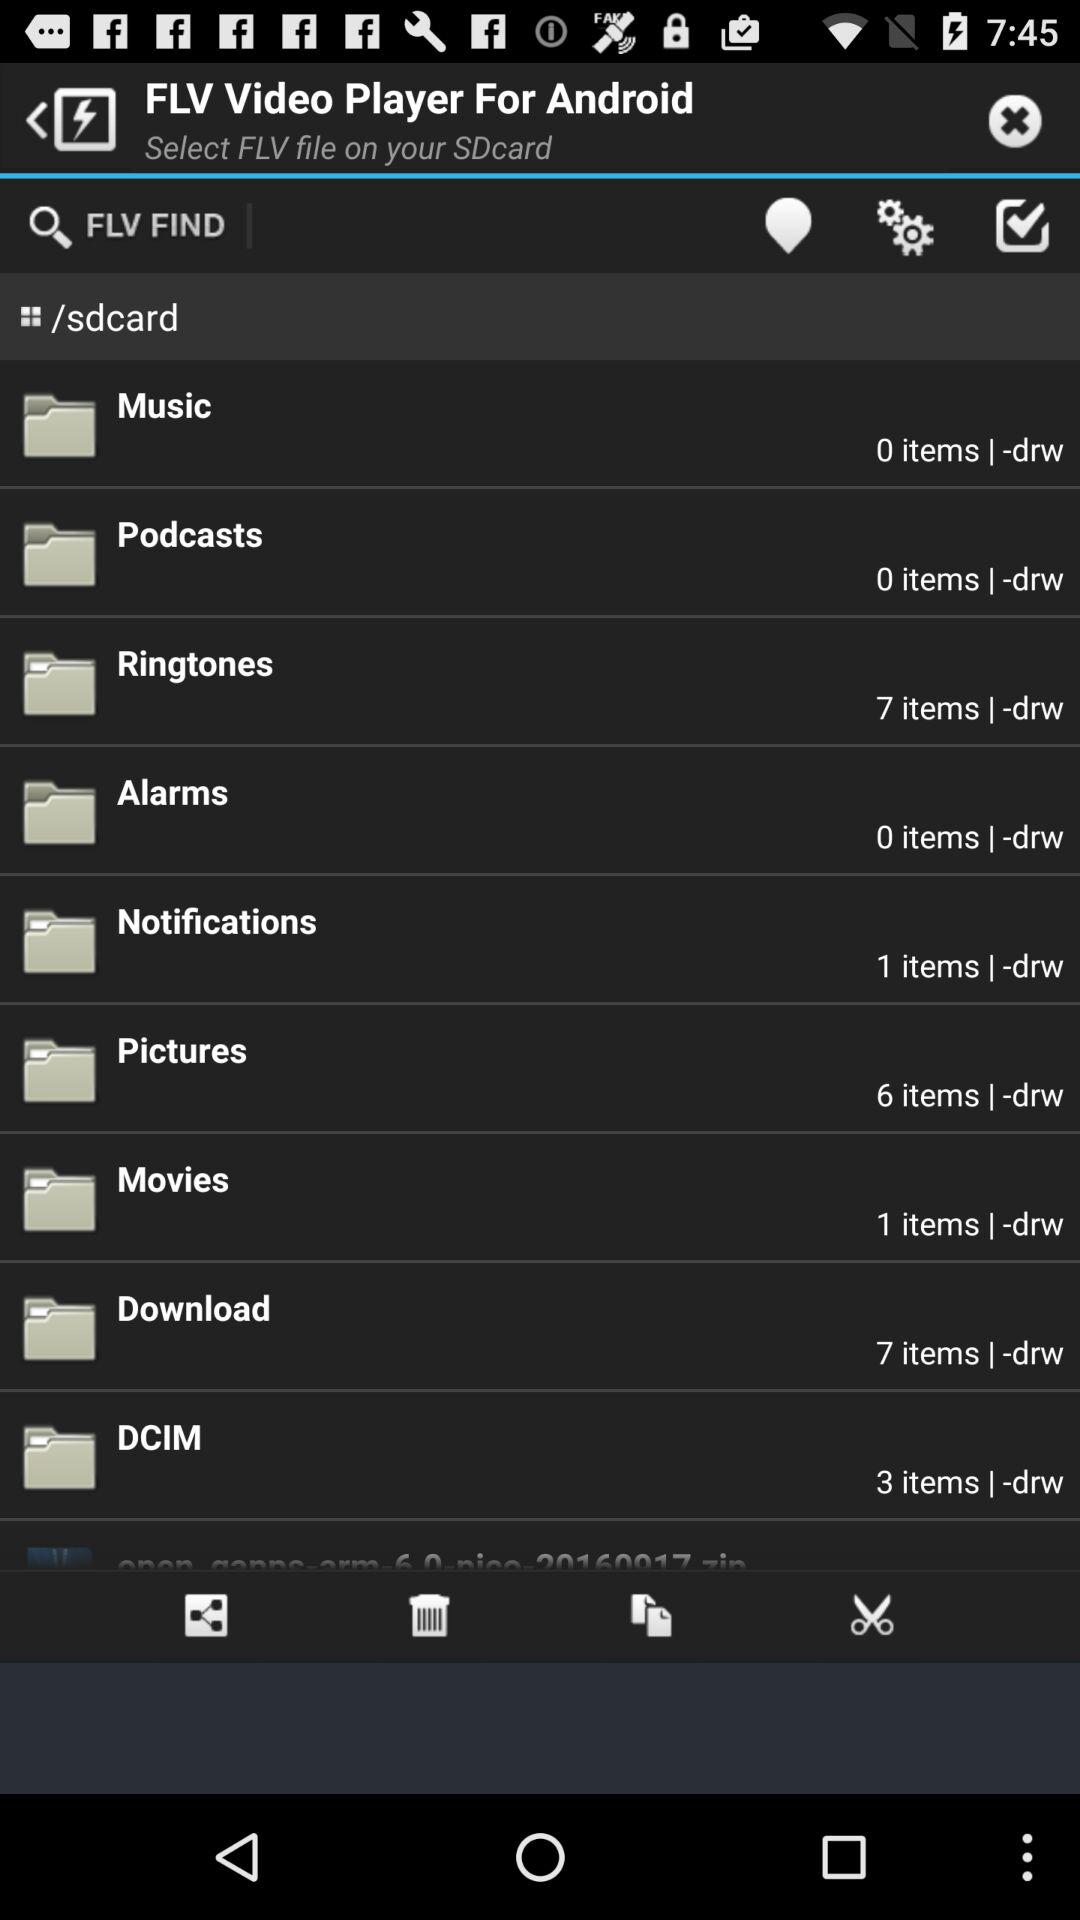Which folder has 6 items? The folder that has 6 items is "Pictures". 